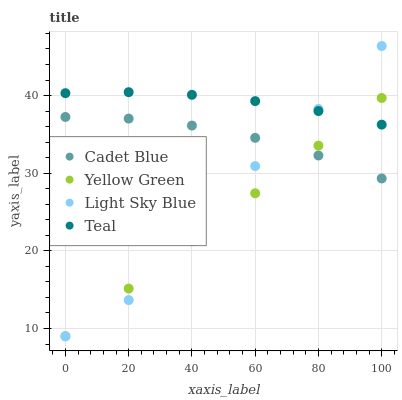Does Yellow Green have the minimum area under the curve?
Answer yes or no. Yes. Does Teal have the maximum area under the curve?
Answer yes or no. Yes. Does Cadet Blue have the minimum area under the curve?
Answer yes or no. No. Does Cadet Blue have the maximum area under the curve?
Answer yes or no. No. Is Yellow Green the smoothest?
Answer yes or no. Yes. Is Light Sky Blue the roughest?
Answer yes or no. Yes. Is Cadet Blue the smoothest?
Answer yes or no. No. Is Cadet Blue the roughest?
Answer yes or no. No. Does Yellow Green have the lowest value?
Answer yes or no. Yes. Does Cadet Blue have the lowest value?
Answer yes or no. No. Does Light Sky Blue have the highest value?
Answer yes or no. Yes. Does Yellow Green have the highest value?
Answer yes or no. No. Is Cadet Blue less than Teal?
Answer yes or no. Yes. Is Teal greater than Cadet Blue?
Answer yes or no. Yes. Does Yellow Green intersect Teal?
Answer yes or no. Yes. Is Yellow Green less than Teal?
Answer yes or no. No. Is Yellow Green greater than Teal?
Answer yes or no. No. Does Cadet Blue intersect Teal?
Answer yes or no. No. 